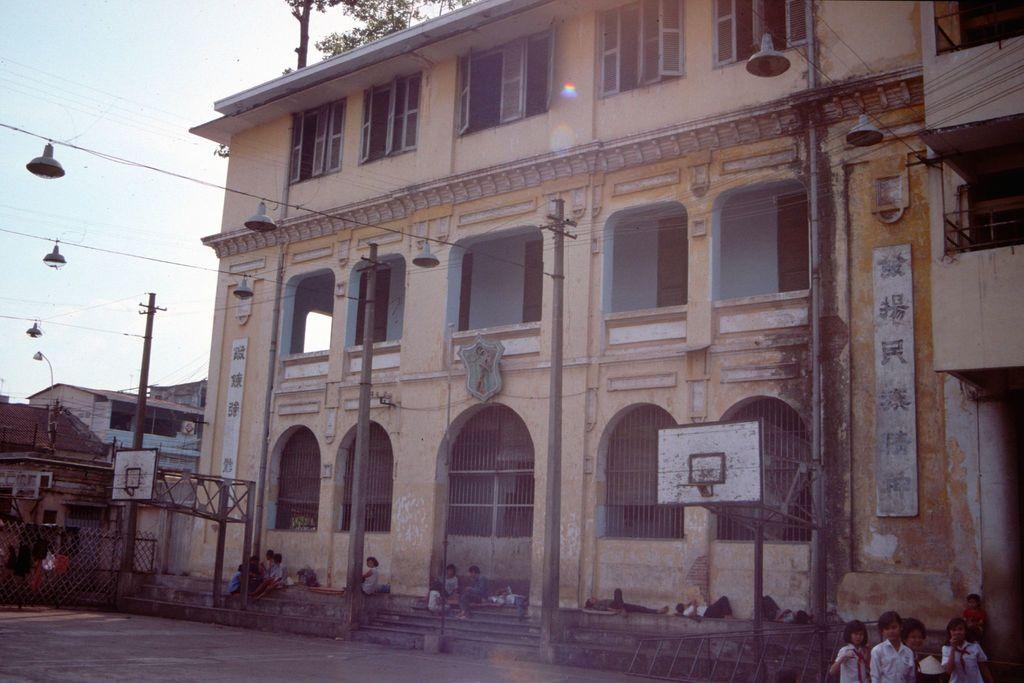Can you describe this image briefly? At the bottom of the image few children are standing, sitting and lying. Behind them there are some poles, buildings and trees. In the top left corner of the image there is sky. 